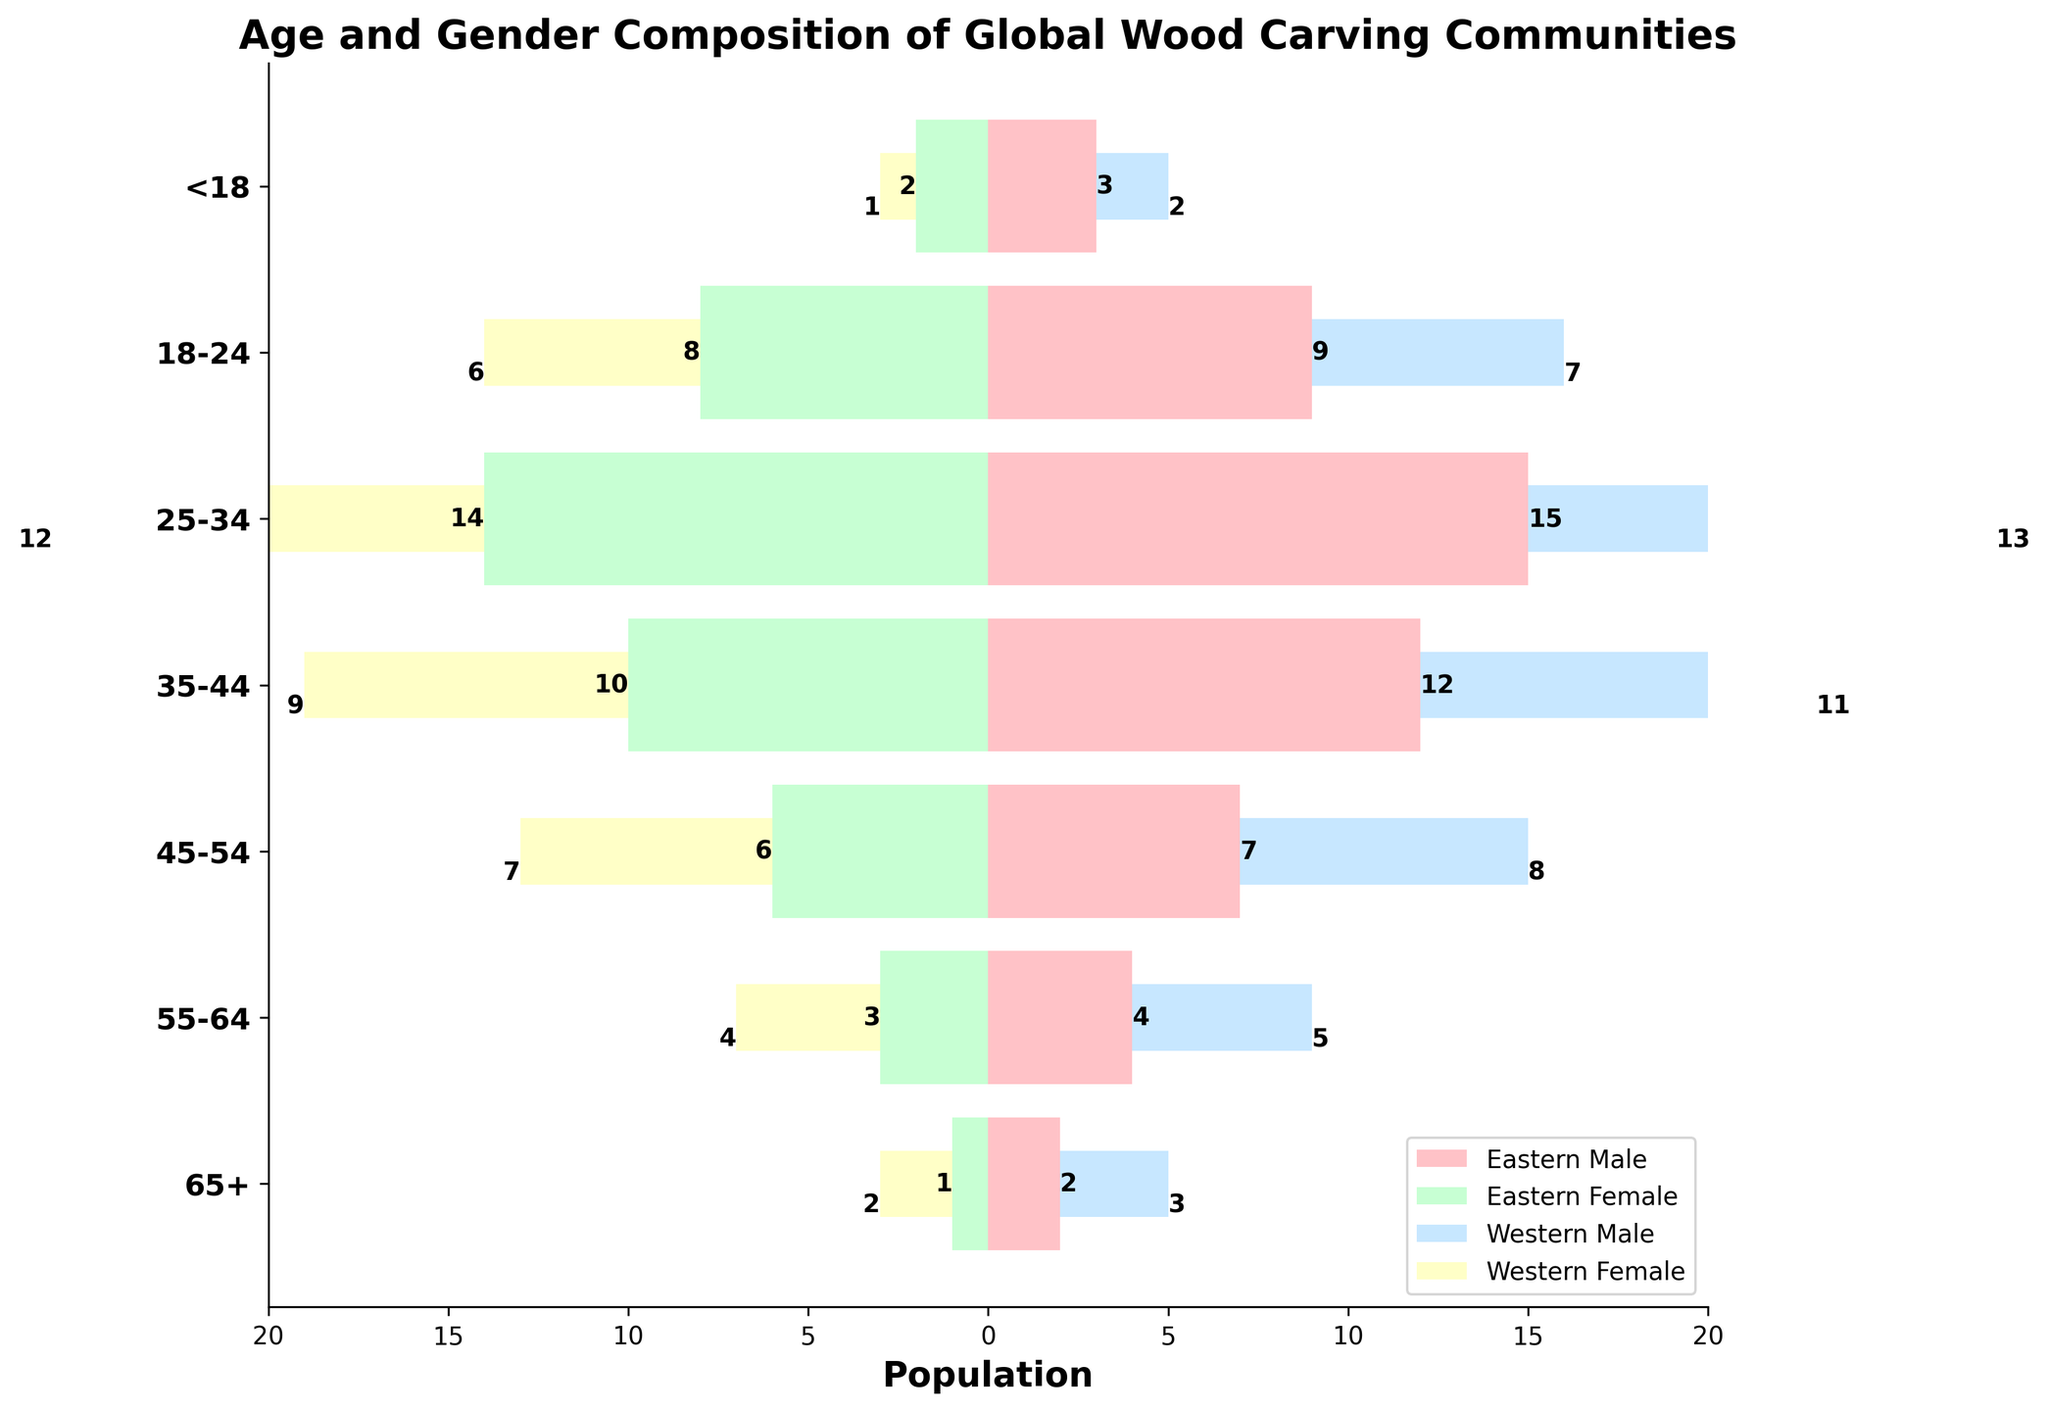What's the title of the figure? The title of the figure is displayed at the top and directly tells us what the figure is about.
Answer: Age and Gender Composition of Global Wood Carving Communities What does the horizontal axis represent? The horizontal axis label is presented at the bottom of the figure, indicating what the horizontal direction measures.
Answer: Population Which age group has the highest population of Eastern Males? By looking at the lengths of the bars representing Eastern Males, we can determine that the age group with the longest bar has the highest population.
Answer: 25-34 In the age group 35-44, which has more population, Eastern Females or Western Females? And by how much? To answer this, we compare the negativized bar lengths of Eastern Females and Western Females in the 35-44 group and find the difference. Eastern Females have 10, Western Females have 9, so the difference is 1.
Answer: Eastern Females by 1 What is the total population for the age group 55-64 in both Eastern and Western communities combined? Summing up the populations of Eastern Males, Eastern Females (absolute value), Western Males, and Western Females in the age group 55-64. (4 + 3 + 5 + 4)
Answer: 16 Which community has a greater number of wood carvers under 18 years old, Eastern or Western? By summing the populations of males and females under 18 years old in the Eastern and Western groups, we find Eastern has (3+2)=5 and Western has (2+1)=3
Answer: Eastern Which age group of Western Males has the smallest population? By comparing the bars for Western Males across all age groups, the one with the smallest value indicates the smallest population. The <18 age group has the smallest bar.
Answer: <18 How does the population of Eastern Males and Western Males in the age group 45-54 compare? Comparing the bar lengths for Eastern Males and Western Males in the 45-54 age group, (7 for Eastern and 8 for Western) showing that Western Males have 1 more person.
Answer: Western Males have 1 more In which age group is the population gap between Eastern Males and Eastern Females the widest? By finding the absolute differences in each age group for Eastern Males and Eastern Females (subtract the lengths of each bar), the widest gap appears in the 25-34 age group (15-14=1).
Answer: 25-34 What is the population difference between the oldest and the youngest age groups of Western Females? Subtract the population of Western Females in the 65+ age group from the <18 age group (2 - 1 = 1).
Answer: 1 